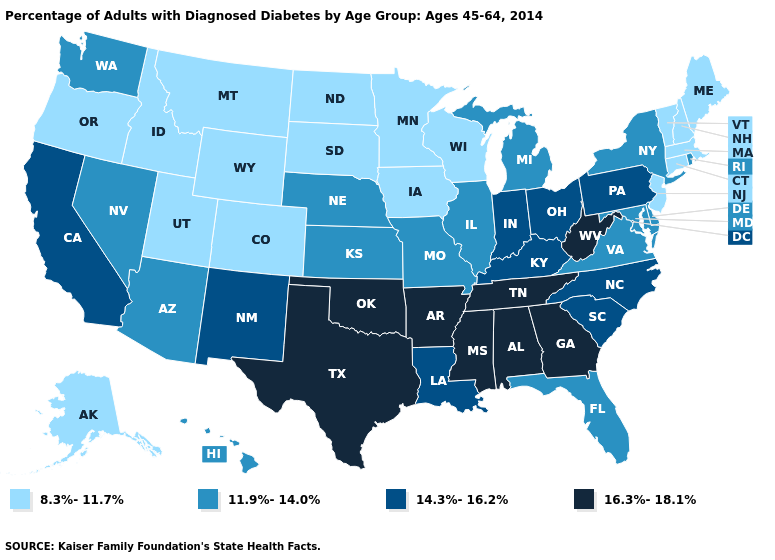Among the states that border Rhode Island , which have the highest value?
Concise answer only. Connecticut, Massachusetts. Does Connecticut have the same value as Massachusetts?
Give a very brief answer. Yes. Among the states that border West Virginia , which have the lowest value?
Answer briefly. Maryland, Virginia. Does Missouri have the lowest value in the MidWest?
Answer briefly. No. Name the states that have a value in the range 14.3%-16.2%?
Quick response, please. California, Indiana, Kentucky, Louisiana, New Mexico, North Carolina, Ohio, Pennsylvania, South Carolina. Does Indiana have the highest value in the MidWest?
Keep it brief. Yes. Does Alabama have the highest value in the USA?
Keep it brief. Yes. Name the states that have a value in the range 11.9%-14.0%?
Be succinct. Arizona, Delaware, Florida, Hawaii, Illinois, Kansas, Maryland, Michigan, Missouri, Nebraska, Nevada, New York, Rhode Island, Virginia, Washington. Among the states that border Minnesota , which have the lowest value?
Keep it brief. Iowa, North Dakota, South Dakota, Wisconsin. Is the legend a continuous bar?
Keep it brief. No. Does Texas have the highest value in the USA?
Keep it brief. Yes. What is the lowest value in states that border Mississippi?
Be succinct. 14.3%-16.2%. Which states have the lowest value in the USA?
Answer briefly. Alaska, Colorado, Connecticut, Idaho, Iowa, Maine, Massachusetts, Minnesota, Montana, New Hampshire, New Jersey, North Dakota, Oregon, South Dakota, Utah, Vermont, Wisconsin, Wyoming. Name the states that have a value in the range 11.9%-14.0%?
Answer briefly. Arizona, Delaware, Florida, Hawaii, Illinois, Kansas, Maryland, Michigan, Missouri, Nebraska, Nevada, New York, Rhode Island, Virginia, Washington. 